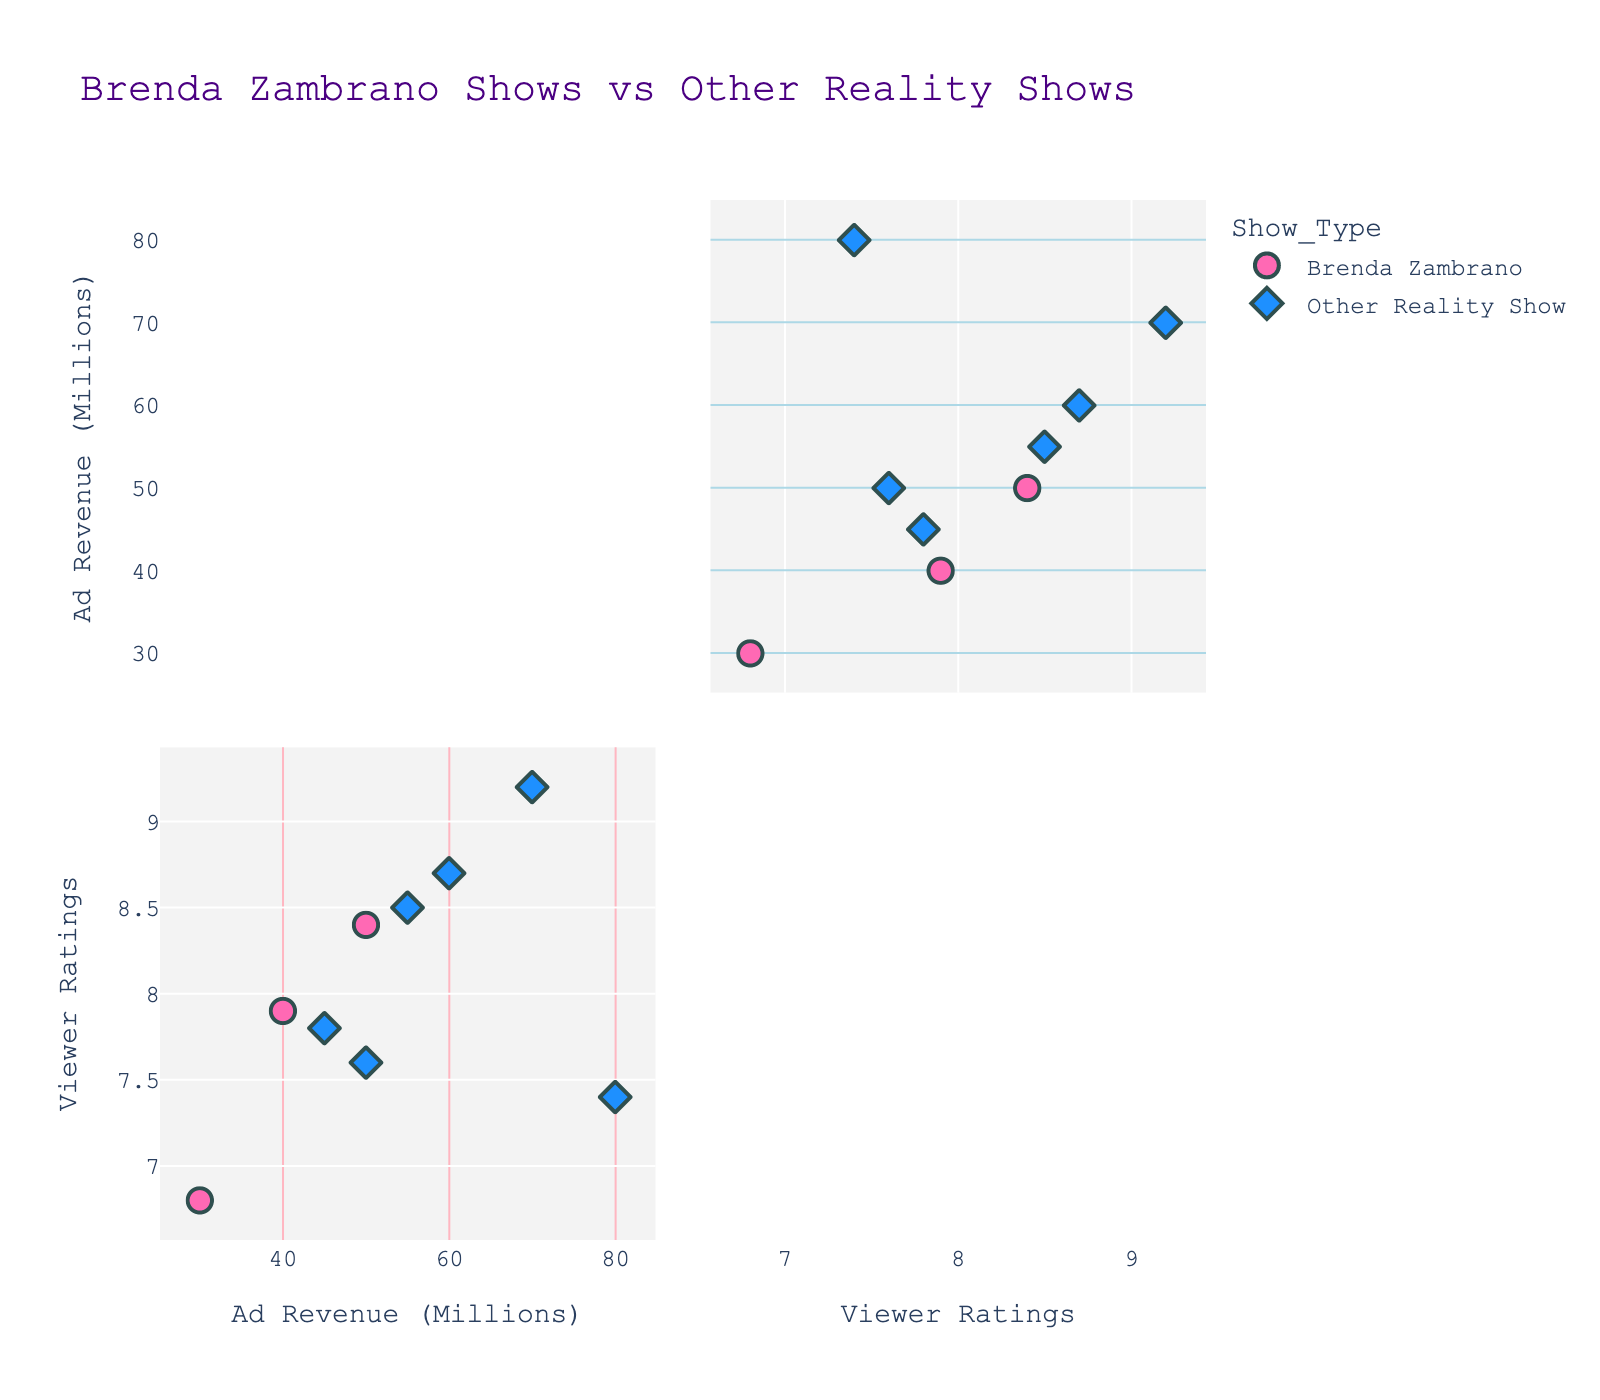What is the title of the figure? The title can be found at the top of the figure. It indicates what the visualization is about. Here, it's "Brenda Zambrano Shows vs Other Reality Shows".
Answer: Brenda Zambrano Shows vs Other Reality Shows What are the dimensions shown in the SPLOM? Look at the axis labels, which indicate the dimensions being visualized. In this case, the axes are labeled "Ad Revenue (Millions)" and "Viewer Ratings".
Answer: Ad Revenue (Millions), Viewer Ratings Which show has the highest advertising revenue? You can find the show with the highest advertising revenue by identifying the data point farthest right on the "Ad Revenue (Millions)" axis. Here, it's "Keeping Up with the Kardashians" with 80 million.
Answer: Keeping Up with the Kardashians Compare the average viewer ratings between Brenda Zambrano's shows and other reality shows. Find all data points for both categories. Calculate the average ratings by summing up the ratings and dividing by the number of shows in each category. Brenda Zambrano's shows (8.4, 7.9, 6.8) sum up to 23.1 over 3 shows, averaging 7.7. Other Reality Shows (9.2, 8.7, 8.5, 7.8, 7.6, 7.4) sum to 49.2 over 6 shows, averaging 8.2.
Answer: Brenda: 7.7, Others: 8.2 Which group has a higher variance in advertising revenue? Variance measures how spread out the values are. Brenda's advertising revenue (50, 40, 30) varies between 30 and 50. Other Reality Shows (70, 60, 55, 45, 50, 80) vary more widely from 45 to 80. Calculate the variance mathematically or visually compare the spread.
Answer: Other Reality Shows Are there more Brenda Zambrano shows or other reality shows in the plot? Count the data points marked with Brenda Zambrano's color and symbol, and those with Other Reality Shows' color and symbol. There are 3 Brenda Zambrano shows and 6 Other Reality Shows.
Answer: Other Reality Shows Which show by Brenda Zambrano has the lowest viewer rating? Look at the data points labeled as Brenda Zambrano's shows and identify the one with the lowest value on the "Viewer Ratings" axis. "Resistiré" has a rating of 6.8.
Answer: Resistiré How does the highest advertising revenue for Brenda Zambrano's shows compare to the highest for other reality shows? Identify the highest advertising revenue for both groups by looking at the farthest right points. Brenda's highest is 50 million, and for other reality shows it's 80 million.
Answer: 50 million vs. 80 million What is the range of viewer ratings for Brenda Zambrano's shows? Find the minimum and maximum ratings for Brenda Zambrano's shows (6.8, 7.9, 8.4) and calculate the range by subtracting the minimum from the maximum.
Answer: Range is 1.6 